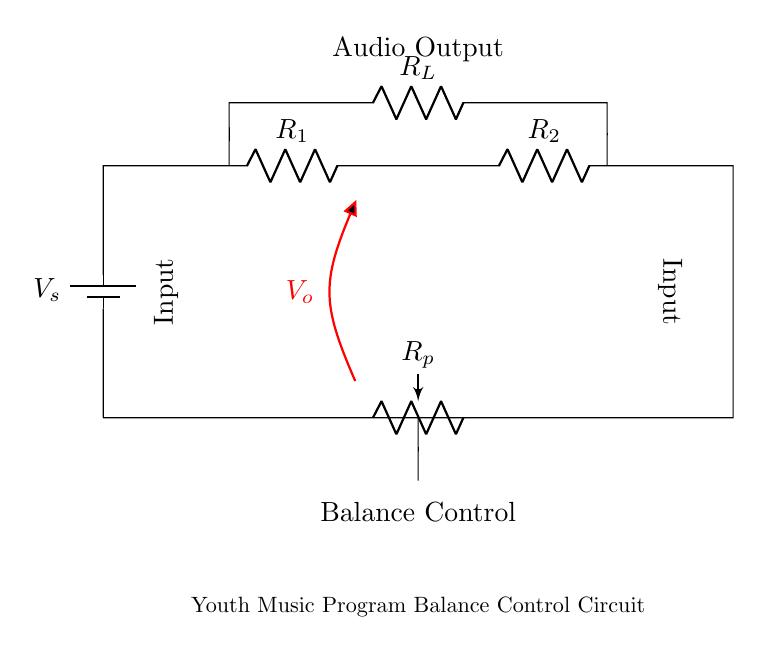What is the type of potentiometer used in this circuit? The circuit diagram indicates that a variable resistor labeled as "R_p" is present, which serves as a potentiometer for balance control.
Answer: variable resistor What does "V_s" represent in the circuit? "V_s" is labeled as the voltage source in the circuit, supplying the necessary electrical power for operation.
Answer: voltage source How many resistors are present in total? The circuit shows a total of four resistors: R_1, R_2, R_L, and R_p.
Answer: four What is the purpose of the "R_L" resistor? R_L is connected in a parallel configuration to provide a load in the circuit, enhancing audio output control.
Answer: load resistor How is the balance controlled in this circuit? The balance is controlled by adjusting the variable resistor "R_p", which changes the resistance in the circuit and alters the output audio levels.
Answer: adjusting R_p What is the main function of the circuit? The primary function of this circuit is to control the audio balance between the left and right channel outputs in a music application.
Answer: audio balance control 